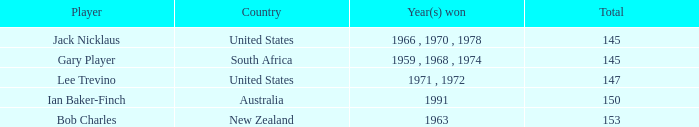What is the lowest To par of gary player, with more than 145 total? None. 